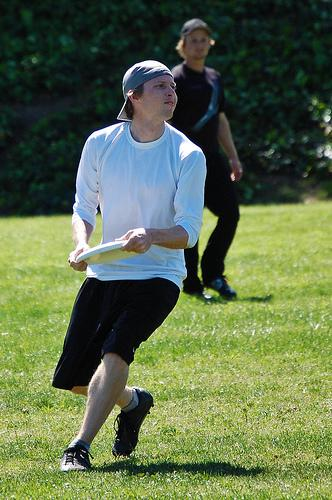Question: what game is being played here?
Choices:
A. Golf.
B. Bowling.
C. Tennis.
D. Frisbee.
Answer with the letter. Answer: D Question: how many people are wearing black?
Choices:
A. One.
B. Three.
C. Two.
D. Five.
Answer with the letter. Answer: C Question: where was this picture likely taken?
Choices:
A. Hospital.
B. Dallas.
C. A park.
D. The Alamo.
Answer with the letter. Answer: C 